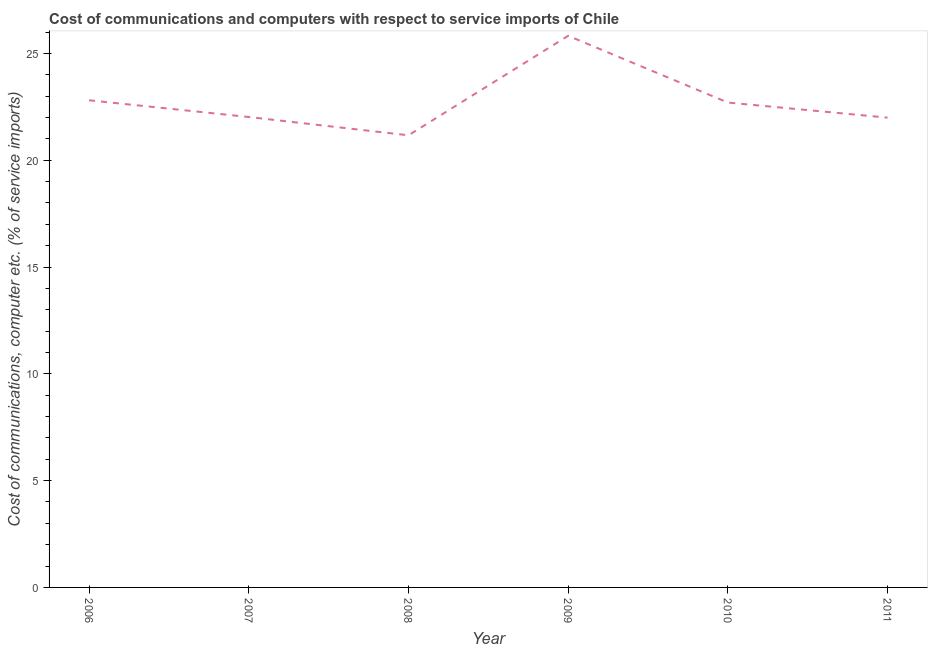What is the cost of communications and computer in 2008?
Make the answer very short. 21.17. Across all years, what is the maximum cost of communications and computer?
Provide a short and direct response. 25.83. Across all years, what is the minimum cost of communications and computer?
Your response must be concise. 21.17. In which year was the cost of communications and computer minimum?
Provide a short and direct response. 2008. What is the sum of the cost of communications and computer?
Ensure brevity in your answer.  136.52. What is the difference between the cost of communications and computer in 2008 and 2011?
Your answer should be very brief. -0.83. What is the average cost of communications and computer per year?
Make the answer very short. 22.75. What is the median cost of communications and computer?
Provide a succinct answer. 22.36. What is the ratio of the cost of communications and computer in 2008 to that in 2010?
Keep it short and to the point. 0.93. Is the difference between the cost of communications and computer in 2007 and 2008 greater than the difference between any two years?
Your response must be concise. No. What is the difference between the highest and the second highest cost of communications and computer?
Your answer should be very brief. 3.02. Is the sum of the cost of communications and computer in 2007 and 2009 greater than the maximum cost of communications and computer across all years?
Make the answer very short. Yes. What is the difference between the highest and the lowest cost of communications and computer?
Your answer should be very brief. 4.66. In how many years, is the cost of communications and computer greater than the average cost of communications and computer taken over all years?
Your answer should be compact. 2. How many years are there in the graph?
Provide a short and direct response. 6. What is the difference between two consecutive major ticks on the Y-axis?
Make the answer very short. 5. Are the values on the major ticks of Y-axis written in scientific E-notation?
Provide a short and direct response. No. Does the graph contain any zero values?
Give a very brief answer. No. What is the title of the graph?
Ensure brevity in your answer.  Cost of communications and computers with respect to service imports of Chile. What is the label or title of the X-axis?
Your answer should be very brief. Year. What is the label or title of the Y-axis?
Your answer should be compact. Cost of communications, computer etc. (% of service imports). What is the Cost of communications, computer etc. (% of service imports) of 2006?
Your response must be concise. 22.81. What is the Cost of communications, computer etc. (% of service imports) of 2007?
Make the answer very short. 22.02. What is the Cost of communications, computer etc. (% of service imports) in 2008?
Provide a short and direct response. 21.17. What is the Cost of communications, computer etc. (% of service imports) in 2009?
Your answer should be compact. 25.83. What is the Cost of communications, computer etc. (% of service imports) of 2010?
Ensure brevity in your answer.  22.7. What is the Cost of communications, computer etc. (% of service imports) in 2011?
Provide a short and direct response. 21.99. What is the difference between the Cost of communications, computer etc. (% of service imports) in 2006 and 2007?
Your answer should be very brief. 0.78. What is the difference between the Cost of communications, computer etc. (% of service imports) in 2006 and 2008?
Ensure brevity in your answer.  1.64. What is the difference between the Cost of communications, computer etc. (% of service imports) in 2006 and 2009?
Provide a short and direct response. -3.02. What is the difference between the Cost of communications, computer etc. (% of service imports) in 2006 and 2010?
Offer a terse response. 0.11. What is the difference between the Cost of communications, computer etc. (% of service imports) in 2006 and 2011?
Offer a very short reply. 0.81. What is the difference between the Cost of communications, computer etc. (% of service imports) in 2007 and 2008?
Your answer should be compact. 0.86. What is the difference between the Cost of communications, computer etc. (% of service imports) in 2007 and 2009?
Give a very brief answer. -3.8. What is the difference between the Cost of communications, computer etc. (% of service imports) in 2007 and 2010?
Keep it short and to the point. -0.68. What is the difference between the Cost of communications, computer etc. (% of service imports) in 2007 and 2011?
Your answer should be very brief. 0.03. What is the difference between the Cost of communications, computer etc. (% of service imports) in 2008 and 2009?
Offer a very short reply. -4.66. What is the difference between the Cost of communications, computer etc. (% of service imports) in 2008 and 2010?
Make the answer very short. -1.53. What is the difference between the Cost of communications, computer etc. (% of service imports) in 2008 and 2011?
Provide a succinct answer. -0.83. What is the difference between the Cost of communications, computer etc. (% of service imports) in 2009 and 2010?
Provide a short and direct response. 3.12. What is the difference between the Cost of communications, computer etc. (% of service imports) in 2009 and 2011?
Your answer should be very brief. 3.83. What is the difference between the Cost of communications, computer etc. (% of service imports) in 2010 and 2011?
Your response must be concise. 0.71. What is the ratio of the Cost of communications, computer etc. (% of service imports) in 2006 to that in 2007?
Your answer should be compact. 1.04. What is the ratio of the Cost of communications, computer etc. (% of service imports) in 2006 to that in 2008?
Provide a short and direct response. 1.08. What is the ratio of the Cost of communications, computer etc. (% of service imports) in 2006 to that in 2009?
Provide a succinct answer. 0.88. What is the ratio of the Cost of communications, computer etc. (% of service imports) in 2007 to that in 2009?
Keep it short and to the point. 0.85. What is the ratio of the Cost of communications, computer etc. (% of service imports) in 2008 to that in 2009?
Your answer should be compact. 0.82. What is the ratio of the Cost of communications, computer etc. (% of service imports) in 2008 to that in 2010?
Ensure brevity in your answer.  0.93. What is the ratio of the Cost of communications, computer etc. (% of service imports) in 2009 to that in 2010?
Provide a short and direct response. 1.14. What is the ratio of the Cost of communications, computer etc. (% of service imports) in 2009 to that in 2011?
Give a very brief answer. 1.17. What is the ratio of the Cost of communications, computer etc. (% of service imports) in 2010 to that in 2011?
Make the answer very short. 1.03. 